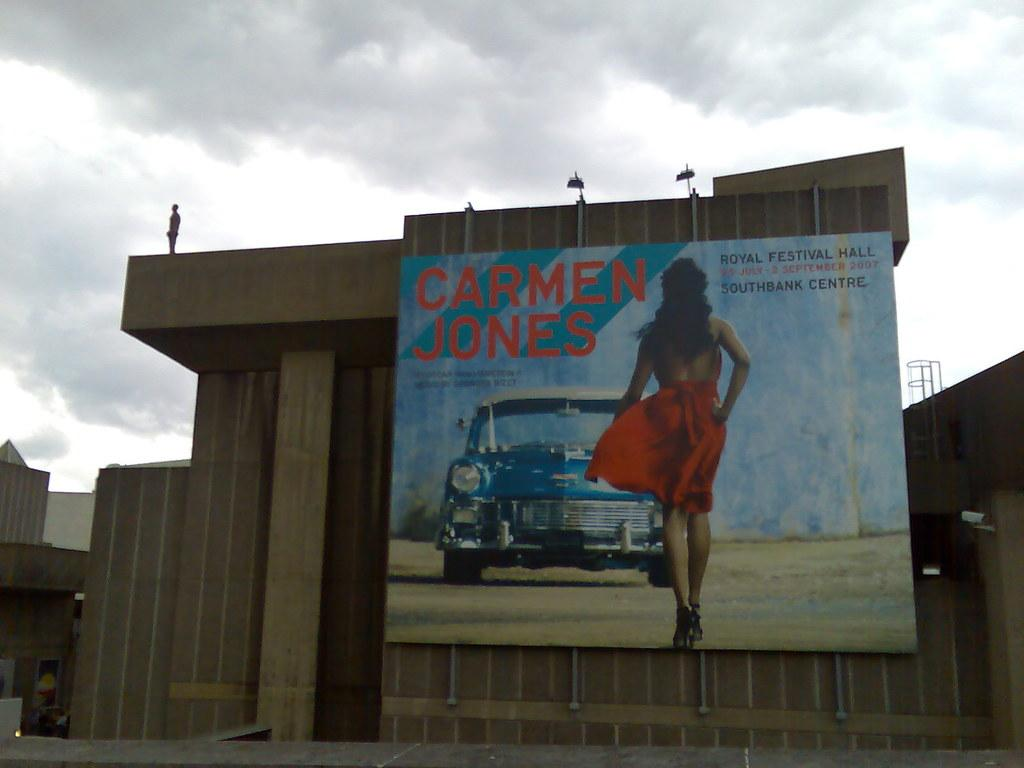<image>
Relay a brief, clear account of the picture shown. a billboard poster of a girl from Carmen Jones 